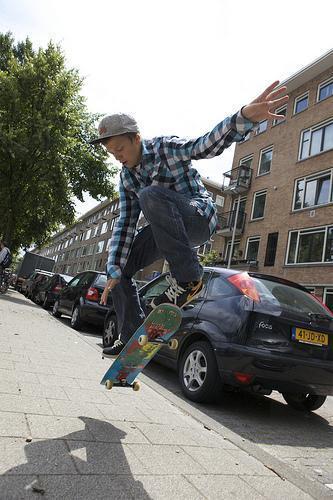How many skateboarders are in in the picture?
Give a very brief answer. 1. How many wheels does the skateboard have?
Give a very brief answer. 4. How many wheels are on the skateboard?
Give a very brief answer. 4. How many digits are on the car's license plate?
Give a very brief answer. 6. How many trees are in the pic?
Give a very brief answer. 1. 